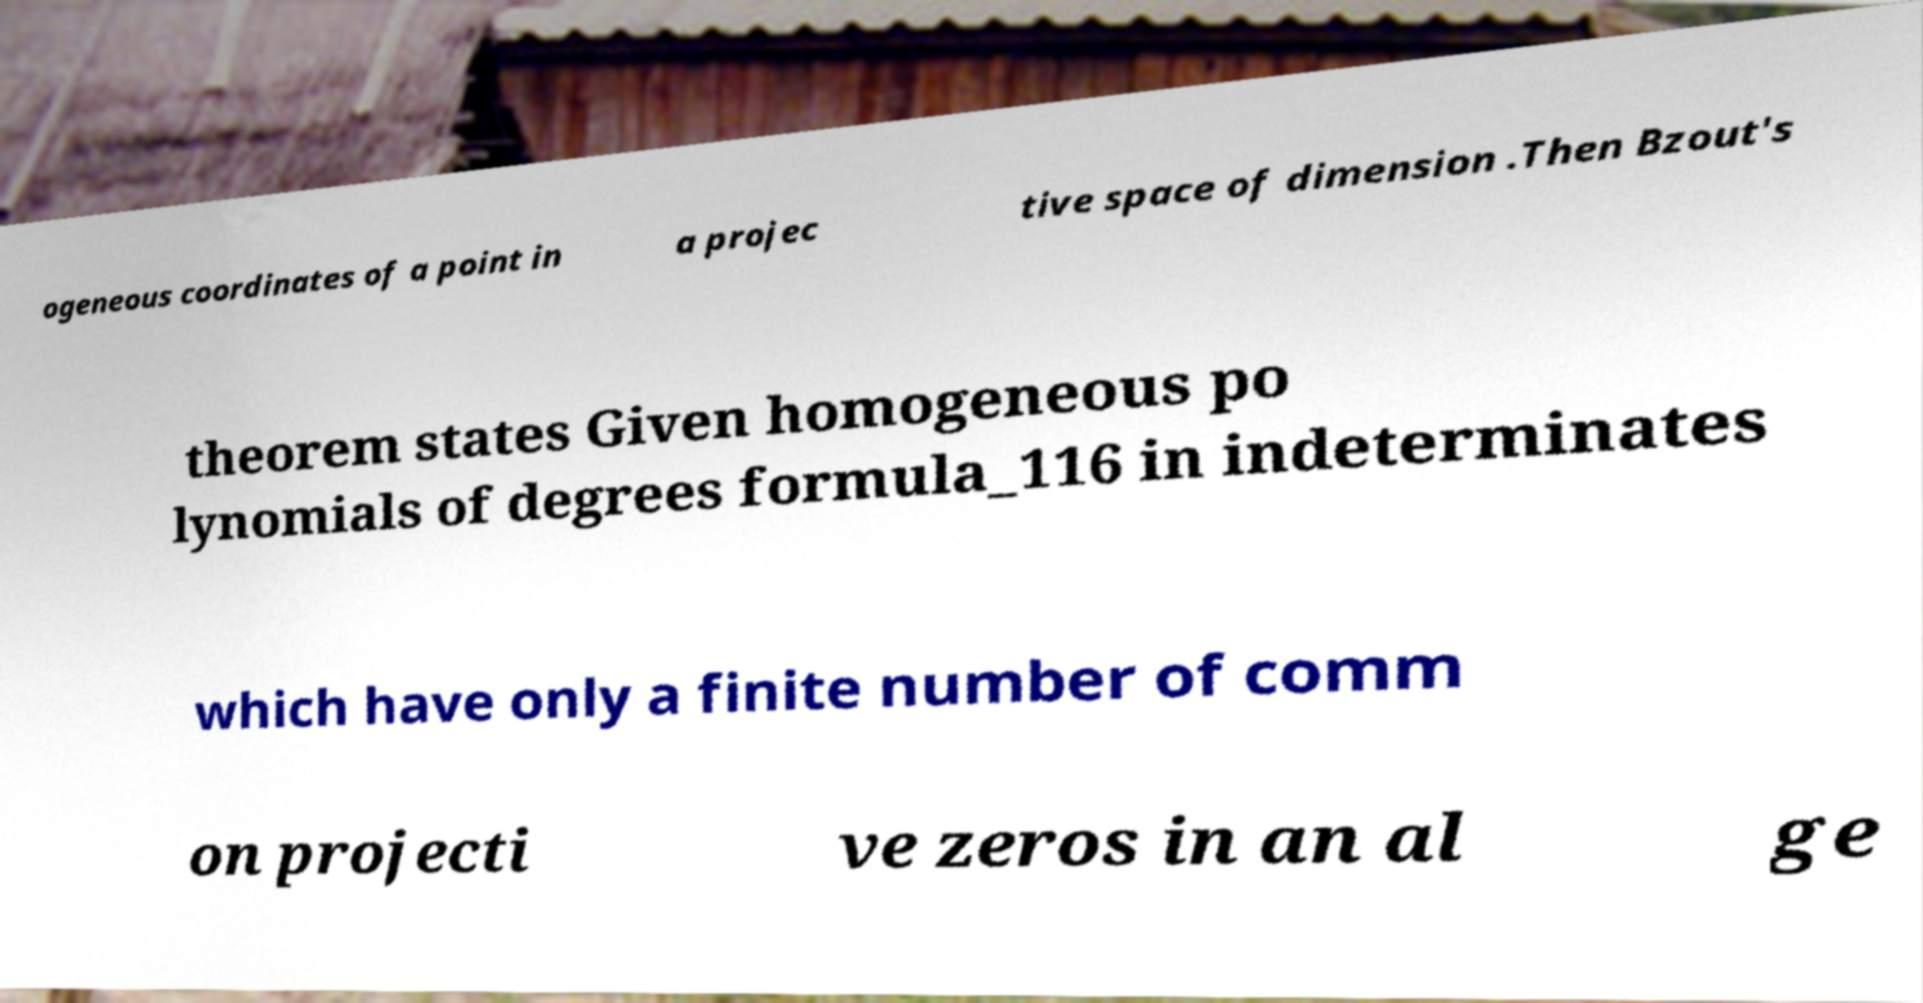For documentation purposes, I need the text within this image transcribed. Could you provide that? ogeneous coordinates of a point in a projec tive space of dimension .Then Bzout's theorem states Given homogeneous po lynomials of degrees formula_116 in indeterminates which have only a finite number of comm on projecti ve zeros in an al ge 